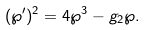<formula> <loc_0><loc_0><loc_500><loc_500>( \wp ^ { \prime } ) ^ { 2 } = 4 \wp ^ { 3 } - g _ { 2 } \wp .</formula> 